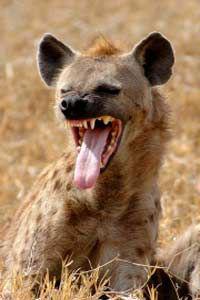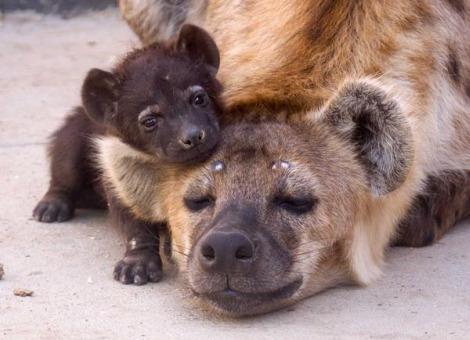The first image is the image on the left, the second image is the image on the right. Given the left and right images, does the statement "The left and right image contains the same number of hyenas." hold true? Answer yes or no. No. The first image is the image on the left, the second image is the image on the right. Analyze the images presented: Is the assertion "Neither image in the pair shows a hyena with it's mouth opened and teeth exposed." valid? Answer yes or no. No. 